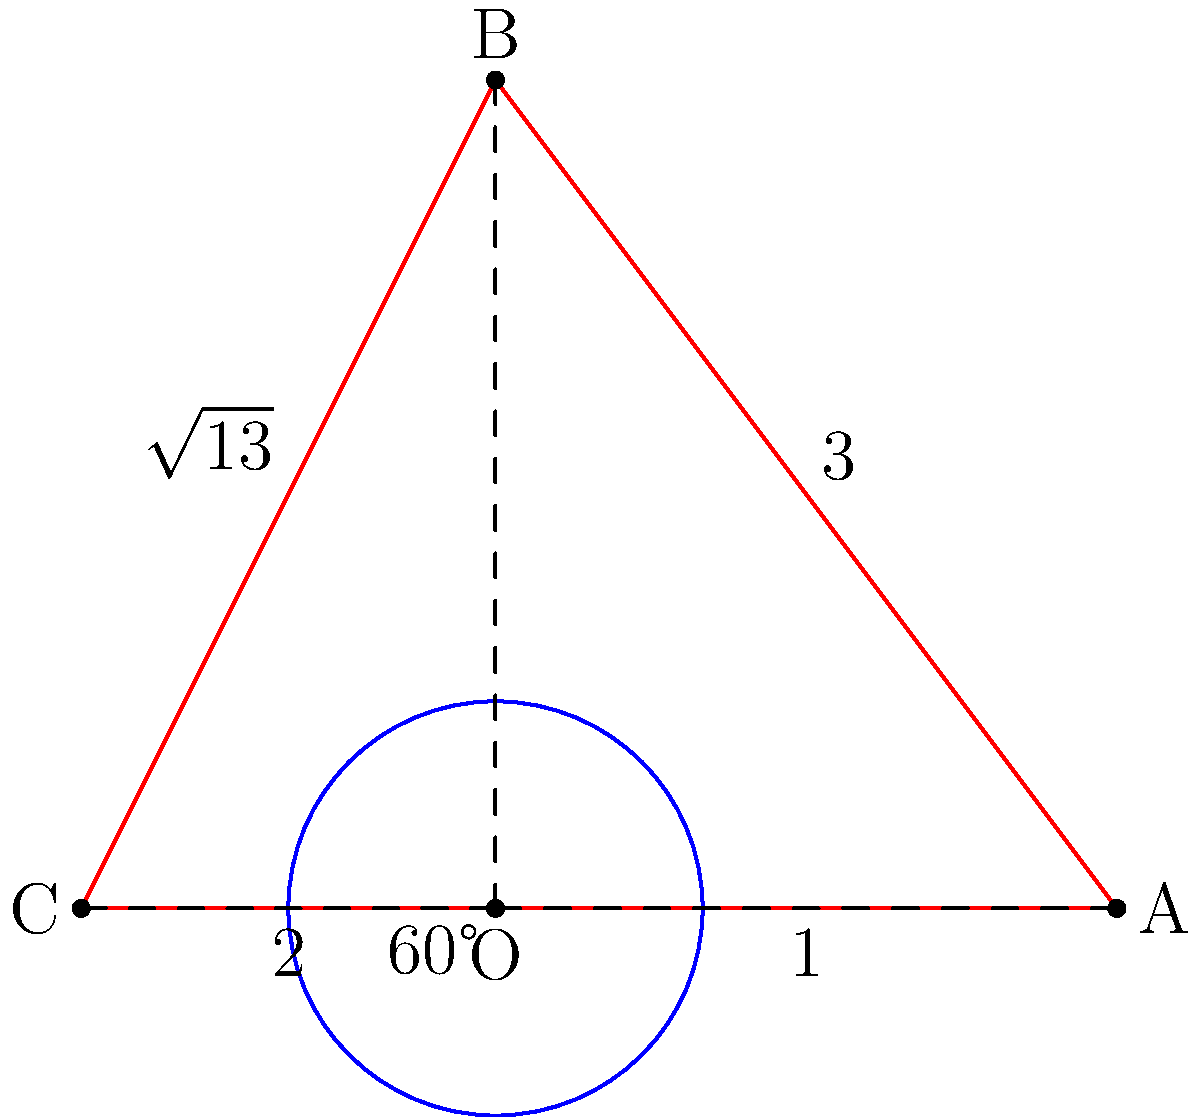Design a minimalist poster using only lines and circles based on the given diagram. The poster should incorporate a triangle ABC with a circumscribed circle centered at O. Given that ∠AOB = 60° and OA = 1 unit, calculate the area of triangle ABC. How does this geometric calculation relate to creating a balanced and proportionate design? Let's approach this step-by-step:

1) First, we need to find the lengths of all sides of the triangle:
   - OA = 1 (given)
   - AB = 3 (shown in the diagram)
   - BC = $\sqrt{13}$ (shown in the diagram)
   - CA = 2 (shown in the diagram)

2) We can use the formula for the area of a triangle given three sides (Heron's formula):
   $A = \sqrt{s(s-a)(s-b)(s-c)}$
   where $s = \frac{a+b+c}{2}$ (semi-perimeter)

3) Calculate s:
   $s = \frac{3 + \sqrt{13} + 2}{2} = \frac{5 + \sqrt{13}}{2}$

4) Now we can plug into Heron's formula:
   $A = \sqrt{\frac{5 + \sqrt{13}}{2} \cdot (\frac{5 + \sqrt{13}}{2} - 3) \cdot (\frac{5 + \sqrt{13}}{2} - \sqrt{13}) \cdot (\frac{5 + \sqrt{13}}{2} - 2)}$

5) Simplify:
   $A = \sqrt{\frac{5 + \sqrt{13}}{2} \cdot \frac{-1 + \sqrt{13}}{2} \cdot \frac{5 - \sqrt{13}}{2} \cdot \frac{1 + \sqrt{13}}{2}}$

6) This simplifies to:
   $A = \frac{\sqrt{39}}{2}$

This geometric calculation relates to creating a balanced and proportionate design by:
- Using the golden ratio ($\sqrt{13}$ is close to the golden ratio)
- Incorporating a perfect 60° angle for visual harmony
- Balancing different geometric shapes (circle and triangle)
- Using precise measurements to create a structured yet creative design
Answer: $\frac{\sqrt{39}}{2}$ square units 